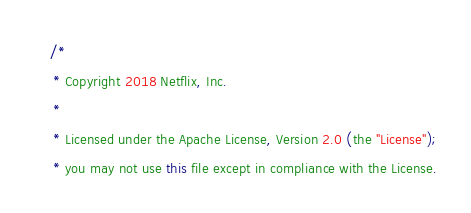<code> <loc_0><loc_0><loc_500><loc_500><_Java_>/*
 * Copyright 2018 Netflix, Inc.
 *
 * Licensed under the Apache License, Version 2.0 (the "License");
 * you may not use this file except in compliance with the License.</code> 